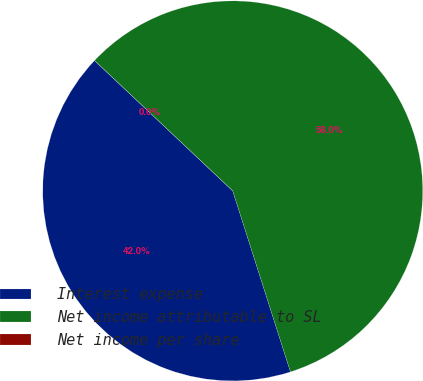<chart> <loc_0><loc_0><loc_500><loc_500><pie_chart><fcel>Interest expense<fcel>Net income attributable to SL<fcel>Net income per share<nl><fcel>41.95%<fcel>58.05%<fcel>0.0%<nl></chart> 